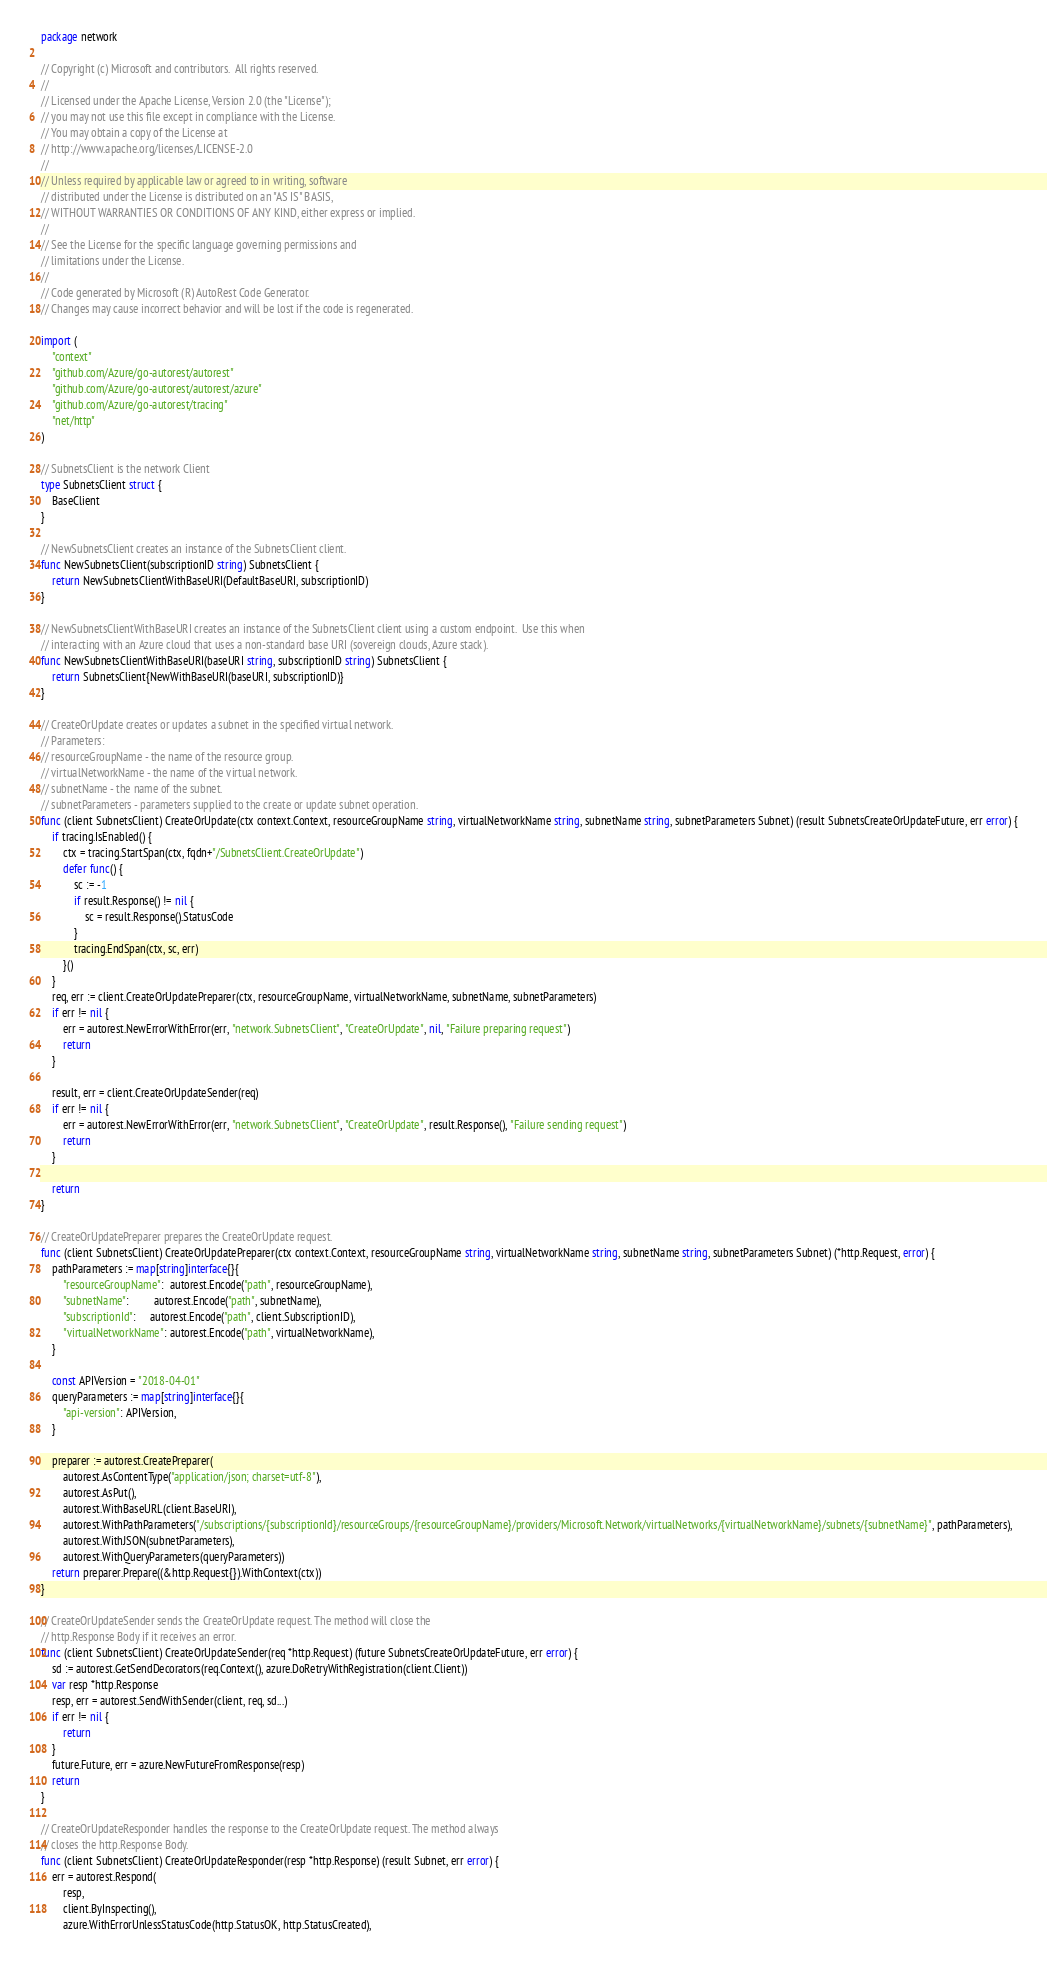<code> <loc_0><loc_0><loc_500><loc_500><_Go_>package network

// Copyright (c) Microsoft and contributors.  All rights reserved.
//
// Licensed under the Apache License, Version 2.0 (the "License");
// you may not use this file except in compliance with the License.
// You may obtain a copy of the License at
// http://www.apache.org/licenses/LICENSE-2.0
//
// Unless required by applicable law or agreed to in writing, software
// distributed under the License is distributed on an "AS IS" BASIS,
// WITHOUT WARRANTIES OR CONDITIONS OF ANY KIND, either express or implied.
//
// See the License for the specific language governing permissions and
// limitations under the License.
//
// Code generated by Microsoft (R) AutoRest Code Generator.
// Changes may cause incorrect behavior and will be lost if the code is regenerated.

import (
	"context"
	"github.com/Azure/go-autorest/autorest"
	"github.com/Azure/go-autorest/autorest/azure"
	"github.com/Azure/go-autorest/tracing"
	"net/http"
)

// SubnetsClient is the network Client
type SubnetsClient struct {
	BaseClient
}

// NewSubnetsClient creates an instance of the SubnetsClient client.
func NewSubnetsClient(subscriptionID string) SubnetsClient {
	return NewSubnetsClientWithBaseURI(DefaultBaseURI, subscriptionID)
}

// NewSubnetsClientWithBaseURI creates an instance of the SubnetsClient client using a custom endpoint.  Use this when
// interacting with an Azure cloud that uses a non-standard base URI (sovereign clouds, Azure stack).
func NewSubnetsClientWithBaseURI(baseURI string, subscriptionID string) SubnetsClient {
	return SubnetsClient{NewWithBaseURI(baseURI, subscriptionID)}
}

// CreateOrUpdate creates or updates a subnet in the specified virtual network.
// Parameters:
// resourceGroupName - the name of the resource group.
// virtualNetworkName - the name of the virtual network.
// subnetName - the name of the subnet.
// subnetParameters - parameters supplied to the create or update subnet operation.
func (client SubnetsClient) CreateOrUpdate(ctx context.Context, resourceGroupName string, virtualNetworkName string, subnetName string, subnetParameters Subnet) (result SubnetsCreateOrUpdateFuture, err error) {
	if tracing.IsEnabled() {
		ctx = tracing.StartSpan(ctx, fqdn+"/SubnetsClient.CreateOrUpdate")
		defer func() {
			sc := -1
			if result.Response() != nil {
				sc = result.Response().StatusCode
			}
			tracing.EndSpan(ctx, sc, err)
		}()
	}
	req, err := client.CreateOrUpdatePreparer(ctx, resourceGroupName, virtualNetworkName, subnetName, subnetParameters)
	if err != nil {
		err = autorest.NewErrorWithError(err, "network.SubnetsClient", "CreateOrUpdate", nil, "Failure preparing request")
		return
	}

	result, err = client.CreateOrUpdateSender(req)
	if err != nil {
		err = autorest.NewErrorWithError(err, "network.SubnetsClient", "CreateOrUpdate", result.Response(), "Failure sending request")
		return
	}

	return
}

// CreateOrUpdatePreparer prepares the CreateOrUpdate request.
func (client SubnetsClient) CreateOrUpdatePreparer(ctx context.Context, resourceGroupName string, virtualNetworkName string, subnetName string, subnetParameters Subnet) (*http.Request, error) {
	pathParameters := map[string]interface{}{
		"resourceGroupName":  autorest.Encode("path", resourceGroupName),
		"subnetName":         autorest.Encode("path", subnetName),
		"subscriptionId":     autorest.Encode("path", client.SubscriptionID),
		"virtualNetworkName": autorest.Encode("path", virtualNetworkName),
	}

	const APIVersion = "2018-04-01"
	queryParameters := map[string]interface{}{
		"api-version": APIVersion,
	}

	preparer := autorest.CreatePreparer(
		autorest.AsContentType("application/json; charset=utf-8"),
		autorest.AsPut(),
		autorest.WithBaseURL(client.BaseURI),
		autorest.WithPathParameters("/subscriptions/{subscriptionId}/resourceGroups/{resourceGroupName}/providers/Microsoft.Network/virtualNetworks/{virtualNetworkName}/subnets/{subnetName}", pathParameters),
		autorest.WithJSON(subnetParameters),
		autorest.WithQueryParameters(queryParameters))
	return preparer.Prepare((&http.Request{}).WithContext(ctx))
}

// CreateOrUpdateSender sends the CreateOrUpdate request. The method will close the
// http.Response Body if it receives an error.
func (client SubnetsClient) CreateOrUpdateSender(req *http.Request) (future SubnetsCreateOrUpdateFuture, err error) {
	sd := autorest.GetSendDecorators(req.Context(), azure.DoRetryWithRegistration(client.Client))
	var resp *http.Response
	resp, err = autorest.SendWithSender(client, req, sd...)
	if err != nil {
		return
	}
	future.Future, err = azure.NewFutureFromResponse(resp)
	return
}

// CreateOrUpdateResponder handles the response to the CreateOrUpdate request. The method always
// closes the http.Response Body.
func (client SubnetsClient) CreateOrUpdateResponder(resp *http.Response) (result Subnet, err error) {
	err = autorest.Respond(
		resp,
		client.ByInspecting(),
		azure.WithErrorUnlessStatusCode(http.StatusOK, http.StatusCreated),</code> 